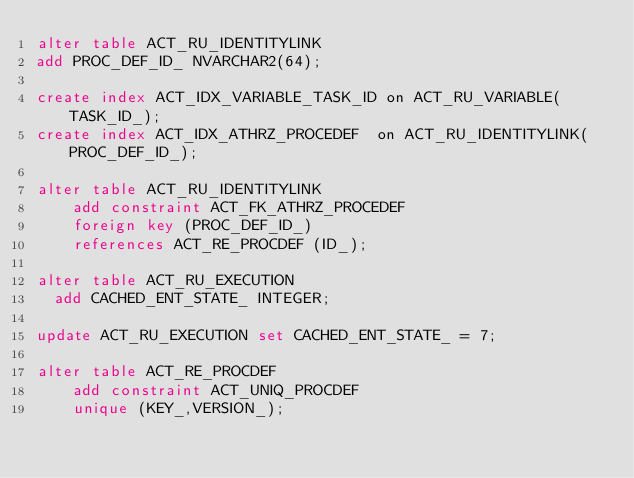Convert code to text. <code><loc_0><loc_0><loc_500><loc_500><_SQL_>alter table ACT_RU_IDENTITYLINK
add PROC_DEF_ID_ NVARCHAR2(64);

create index ACT_IDX_VARIABLE_TASK_ID on ACT_RU_VARIABLE(TASK_ID_);
create index ACT_IDX_ATHRZ_PROCEDEF  on ACT_RU_IDENTITYLINK(PROC_DEF_ID_);

alter table ACT_RU_IDENTITYLINK
    add constraint ACT_FK_ATHRZ_PROCEDEF
    foreign key (PROC_DEF_ID_)
    references ACT_RE_PROCDEF (ID_);

alter table ACT_RU_EXECUTION
	add CACHED_ENT_STATE_ INTEGER;

update ACT_RU_EXECUTION set CACHED_ENT_STATE_ = 7;

alter table ACT_RE_PROCDEF
    add constraint ACT_UNIQ_PROCDEF
    unique (KEY_,VERSION_);
</code> 